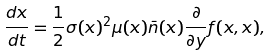<formula> <loc_0><loc_0><loc_500><loc_500>\frac { d x } { d t } = \frac { 1 } { 2 } \sigma ( x ) ^ { 2 } { \mu ( x ) } { \bar { n } ( x ) } \frac { \partial } { \partial y } { f ( x , x ) } ,</formula> 